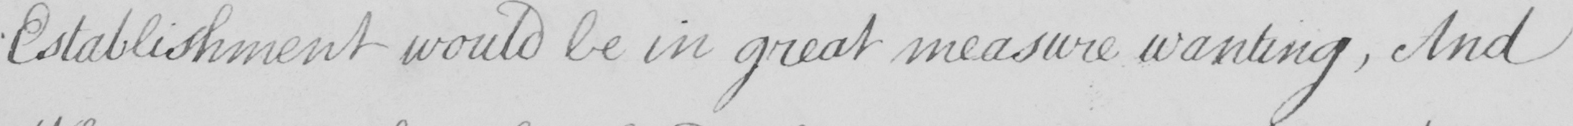Please transcribe the handwritten text in this image. Establishment would be in great measure wanting  , And 